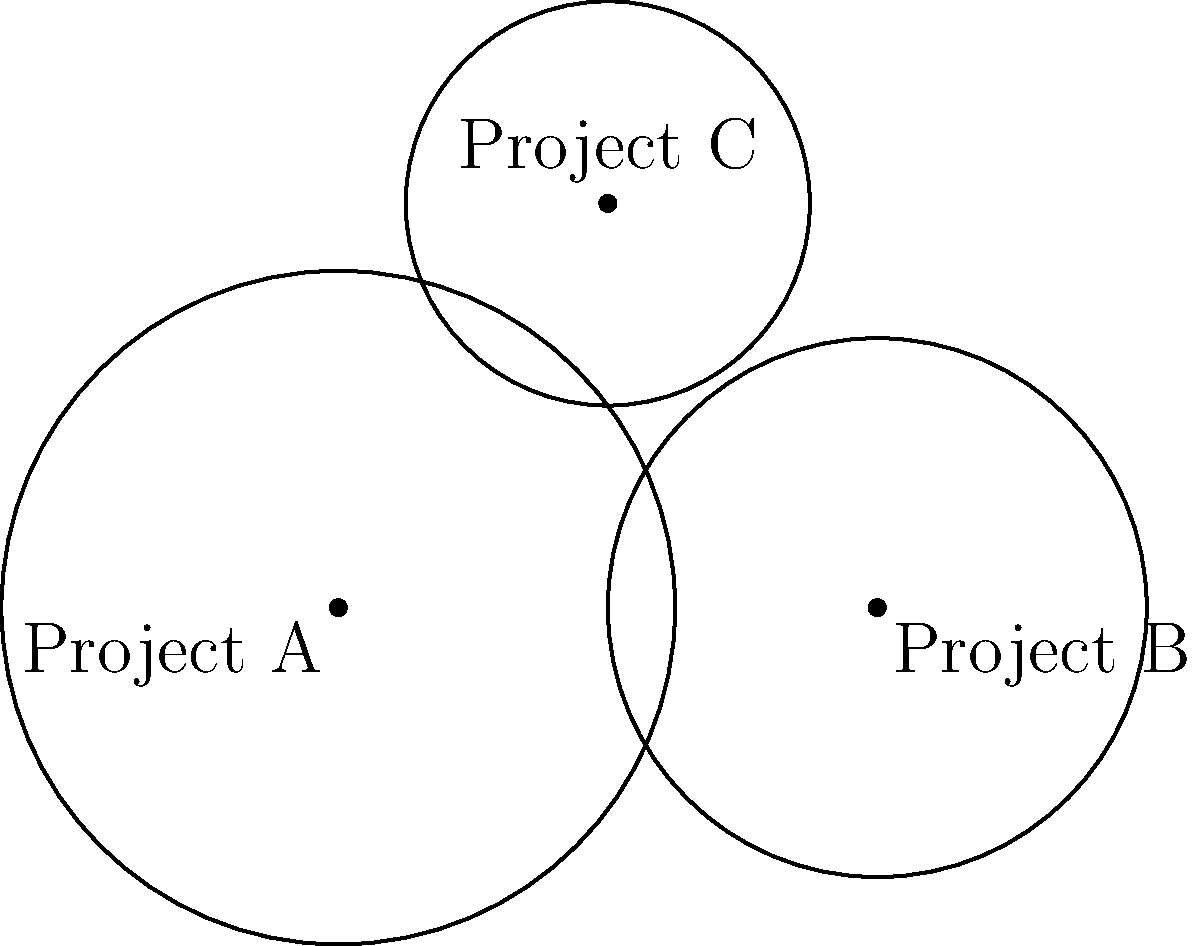In a grant distribution program for entrepreneurs, three projects (A, B, and C) have been identified with different market reach. Their locations and market radii are represented by circles in the diagram. Project A has a market radius of 2.5 units, Project B has 2 units, and Project C has 1.5 units. What is the minimum number of projects that need to be funded to ensure at least 90% coverage of the total market area? To solve this problem, we need to follow these steps:

1. Calculate the total area covered by all three projects:
   $$A_{total} = \pi r_A^2 + \pi r_B^2 + \pi r_C^2$$
   $$A_{total} = \pi(2.5^2 + 2^2 + 1.5^2) \approx 32.99$$

2. Calculate 90% of the total area:
   $$A_{90\%} = 0.9 \times 32.99 \approx 29.69$$

3. Start with the largest project (A) and calculate its area:
   $$A_A = \pi r_A^2 = \pi(2.5^2) \approx 19.63$$

4. This is not enough, so add the next largest project (B):
   $$A_{A+B} = \pi(2.5^2 + 2^2) \approx 32.17$$

5. The combined area of Projects A and B exceeds 90% of the total area (32.17 > 29.69).

Therefore, funding the two largest projects (A and B) is sufficient to cover at least 90% of the total market area.
Answer: 2 projects 